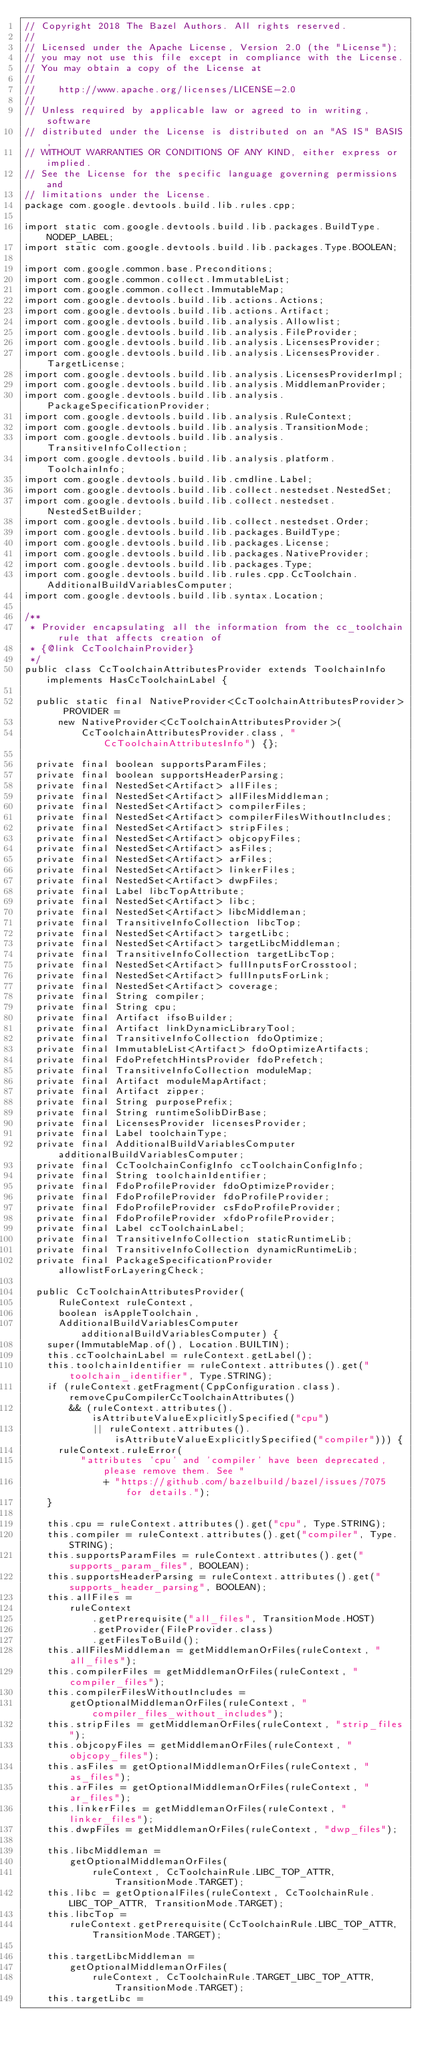<code> <loc_0><loc_0><loc_500><loc_500><_Java_>// Copyright 2018 The Bazel Authors. All rights reserved.
//
// Licensed under the Apache License, Version 2.0 (the "License");
// you may not use this file except in compliance with the License.
// You may obtain a copy of the License at
//
//    http://www.apache.org/licenses/LICENSE-2.0
//
// Unless required by applicable law or agreed to in writing, software
// distributed under the License is distributed on an "AS IS" BASIS,
// WITHOUT WARRANTIES OR CONDITIONS OF ANY KIND, either express or implied.
// See the License for the specific language governing permissions and
// limitations under the License.
package com.google.devtools.build.lib.rules.cpp;

import static com.google.devtools.build.lib.packages.BuildType.NODEP_LABEL;
import static com.google.devtools.build.lib.packages.Type.BOOLEAN;

import com.google.common.base.Preconditions;
import com.google.common.collect.ImmutableList;
import com.google.common.collect.ImmutableMap;
import com.google.devtools.build.lib.actions.Actions;
import com.google.devtools.build.lib.actions.Artifact;
import com.google.devtools.build.lib.analysis.Allowlist;
import com.google.devtools.build.lib.analysis.FileProvider;
import com.google.devtools.build.lib.analysis.LicensesProvider;
import com.google.devtools.build.lib.analysis.LicensesProvider.TargetLicense;
import com.google.devtools.build.lib.analysis.LicensesProviderImpl;
import com.google.devtools.build.lib.analysis.MiddlemanProvider;
import com.google.devtools.build.lib.analysis.PackageSpecificationProvider;
import com.google.devtools.build.lib.analysis.RuleContext;
import com.google.devtools.build.lib.analysis.TransitionMode;
import com.google.devtools.build.lib.analysis.TransitiveInfoCollection;
import com.google.devtools.build.lib.analysis.platform.ToolchainInfo;
import com.google.devtools.build.lib.cmdline.Label;
import com.google.devtools.build.lib.collect.nestedset.NestedSet;
import com.google.devtools.build.lib.collect.nestedset.NestedSetBuilder;
import com.google.devtools.build.lib.collect.nestedset.Order;
import com.google.devtools.build.lib.packages.BuildType;
import com.google.devtools.build.lib.packages.License;
import com.google.devtools.build.lib.packages.NativeProvider;
import com.google.devtools.build.lib.packages.Type;
import com.google.devtools.build.lib.rules.cpp.CcToolchain.AdditionalBuildVariablesComputer;
import com.google.devtools.build.lib.syntax.Location;

/**
 * Provider encapsulating all the information from the cc_toolchain rule that affects creation of
 * {@link CcToolchainProvider}
 */
public class CcToolchainAttributesProvider extends ToolchainInfo implements HasCcToolchainLabel {

  public static final NativeProvider<CcToolchainAttributesProvider> PROVIDER =
      new NativeProvider<CcToolchainAttributesProvider>(
          CcToolchainAttributesProvider.class, "CcToolchainAttributesInfo") {};

  private final boolean supportsParamFiles;
  private final boolean supportsHeaderParsing;
  private final NestedSet<Artifact> allFiles;
  private final NestedSet<Artifact> allFilesMiddleman;
  private final NestedSet<Artifact> compilerFiles;
  private final NestedSet<Artifact> compilerFilesWithoutIncludes;
  private final NestedSet<Artifact> stripFiles;
  private final NestedSet<Artifact> objcopyFiles;
  private final NestedSet<Artifact> asFiles;
  private final NestedSet<Artifact> arFiles;
  private final NestedSet<Artifact> linkerFiles;
  private final NestedSet<Artifact> dwpFiles;
  private final Label libcTopAttribute;
  private final NestedSet<Artifact> libc;
  private final NestedSet<Artifact> libcMiddleman;
  private final TransitiveInfoCollection libcTop;
  private final NestedSet<Artifact> targetLibc;
  private final NestedSet<Artifact> targetLibcMiddleman;
  private final TransitiveInfoCollection targetLibcTop;
  private final NestedSet<Artifact> fullInputsForCrosstool;
  private final NestedSet<Artifact> fullInputsForLink;
  private final NestedSet<Artifact> coverage;
  private final String compiler;
  private final String cpu;
  private final Artifact ifsoBuilder;
  private final Artifact linkDynamicLibraryTool;
  private final TransitiveInfoCollection fdoOptimize;
  private final ImmutableList<Artifact> fdoOptimizeArtifacts;
  private final FdoPrefetchHintsProvider fdoPrefetch;
  private final TransitiveInfoCollection moduleMap;
  private final Artifact moduleMapArtifact;
  private final Artifact zipper;
  private final String purposePrefix;
  private final String runtimeSolibDirBase;
  private final LicensesProvider licensesProvider;
  private final Label toolchainType;
  private final AdditionalBuildVariablesComputer additionalBuildVariablesComputer;
  private final CcToolchainConfigInfo ccToolchainConfigInfo;
  private final String toolchainIdentifier;
  private final FdoProfileProvider fdoOptimizeProvider;
  private final FdoProfileProvider fdoProfileProvider;
  private final FdoProfileProvider csFdoProfileProvider;
  private final FdoProfileProvider xfdoProfileProvider;
  private final Label ccToolchainLabel;
  private final TransitiveInfoCollection staticRuntimeLib;
  private final TransitiveInfoCollection dynamicRuntimeLib;
  private final PackageSpecificationProvider allowlistForLayeringCheck;

  public CcToolchainAttributesProvider(
      RuleContext ruleContext,
      boolean isAppleToolchain,
      AdditionalBuildVariablesComputer additionalBuildVariablesComputer) {
    super(ImmutableMap.of(), Location.BUILTIN);
    this.ccToolchainLabel = ruleContext.getLabel();
    this.toolchainIdentifier = ruleContext.attributes().get("toolchain_identifier", Type.STRING);
    if (ruleContext.getFragment(CppConfiguration.class).removeCpuCompilerCcToolchainAttributes()
        && (ruleContext.attributes().isAttributeValueExplicitlySpecified("cpu")
            || ruleContext.attributes().isAttributeValueExplicitlySpecified("compiler"))) {
      ruleContext.ruleError(
          "attributes 'cpu' and 'compiler' have been deprecated, please remove them. See "
              + "https://github.com/bazelbuild/bazel/issues/7075 for details.");
    }

    this.cpu = ruleContext.attributes().get("cpu", Type.STRING);
    this.compiler = ruleContext.attributes().get("compiler", Type.STRING);
    this.supportsParamFiles = ruleContext.attributes().get("supports_param_files", BOOLEAN);
    this.supportsHeaderParsing = ruleContext.attributes().get("supports_header_parsing", BOOLEAN);
    this.allFiles =
        ruleContext
            .getPrerequisite("all_files", TransitionMode.HOST)
            .getProvider(FileProvider.class)
            .getFilesToBuild();
    this.allFilesMiddleman = getMiddlemanOrFiles(ruleContext, "all_files");
    this.compilerFiles = getMiddlemanOrFiles(ruleContext, "compiler_files");
    this.compilerFilesWithoutIncludes =
        getOptionalMiddlemanOrFiles(ruleContext, "compiler_files_without_includes");
    this.stripFiles = getMiddlemanOrFiles(ruleContext, "strip_files");
    this.objcopyFiles = getMiddlemanOrFiles(ruleContext, "objcopy_files");
    this.asFiles = getOptionalMiddlemanOrFiles(ruleContext, "as_files");
    this.arFiles = getOptionalMiddlemanOrFiles(ruleContext, "ar_files");
    this.linkerFiles = getMiddlemanOrFiles(ruleContext, "linker_files");
    this.dwpFiles = getMiddlemanOrFiles(ruleContext, "dwp_files");

    this.libcMiddleman =
        getOptionalMiddlemanOrFiles(
            ruleContext, CcToolchainRule.LIBC_TOP_ATTR, TransitionMode.TARGET);
    this.libc = getOptionalFiles(ruleContext, CcToolchainRule.LIBC_TOP_ATTR, TransitionMode.TARGET);
    this.libcTop =
        ruleContext.getPrerequisite(CcToolchainRule.LIBC_TOP_ATTR, TransitionMode.TARGET);

    this.targetLibcMiddleman =
        getOptionalMiddlemanOrFiles(
            ruleContext, CcToolchainRule.TARGET_LIBC_TOP_ATTR, TransitionMode.TARGET);
    this.targetLibc =</code> 